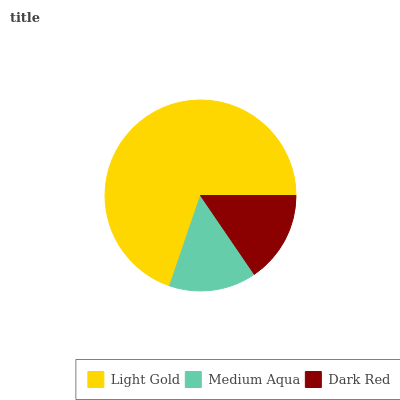Is Medium Aqua the minimum?
Answer yes or no. Yes. Is Light Gold the maximum?
Answer yes or no. Yes. Is Dark Red the minimum?
Answer yes or no. No. Is Dark Red the maximum?
Answer yes or no. No. Is Dark Red greater than Medium Aqua?
Answer yes or no. Yes. Is Medium Aqua less than Dark Red?
Answer yes or no. Yes. Is Medium Aqua greater than Dark Red?
Answer yes or no. No. Is Dark Red less than Medium Aqua?
Answer yes or no. No. Is Dark Red the high median?
Answer yes or no. Yes. Is Dark Red the low median?
Answer yes or no. Yes. Is Medium Aqua the high median?
Answer yes or no. No. Is Light Gold the low median?
Answer yes or no. No. 